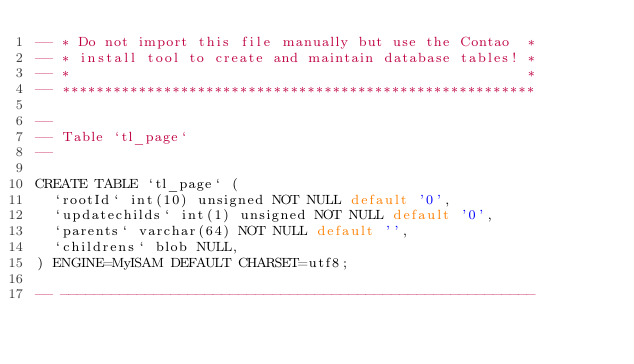<code> <loc_0><loc_0><loc_500><loc_500><_SQL_>-- * Do not import this file manually but use the Contao  *
-- * install tool to create and maintain database tables! *
-- *                                                      *
-- ********************************************************

-- 
-- Table `tl_page`
-- 

CREATE TABLE `tl_page` (
  `rootId` int(10) unsigned NOT NULL default '0',
  `updatechilds` int(1) unsigned NOT NULL default '0',
  `parents` varchar(64) NOT NULL default '',
  `childrens` blob NULL,
) ENGINE=MyISAM DEFAULT CHARSET=utf8;

-- --------------------------------------------------------
</code> 